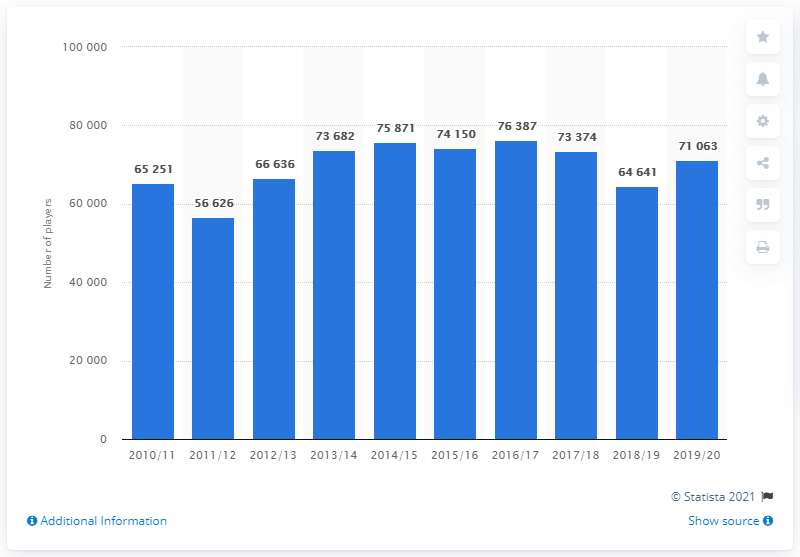Give some essential details in this illustration. In the 2019/2020 season, there were 71,063 registered ice hockey players. In the 2016/2017 season, a total of 76,387 players participated. 